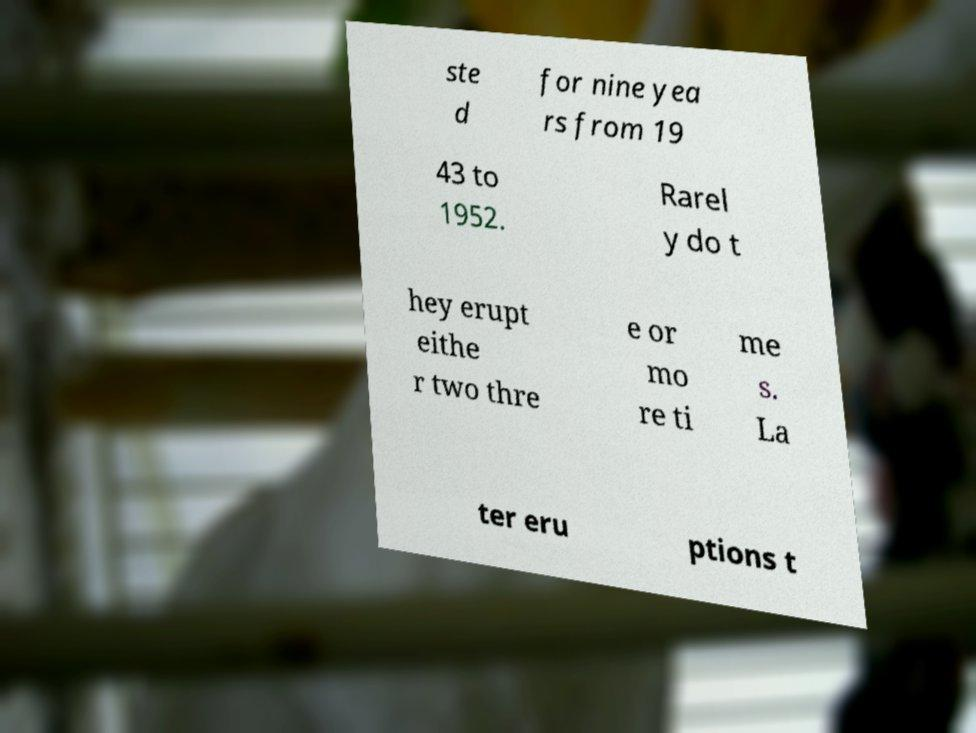For documentation purposes, I need the text within this image transcribed. Could you provide that? ste d for nine yea rs from 19 43 to 1952. Rarel y do t hey erupt eithe r two thre e or mo re ti me s. La ter eru ptions t 